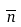<formula> <loc_0><loc_0><loc_500><loc_500>\overline { n }</formula> 